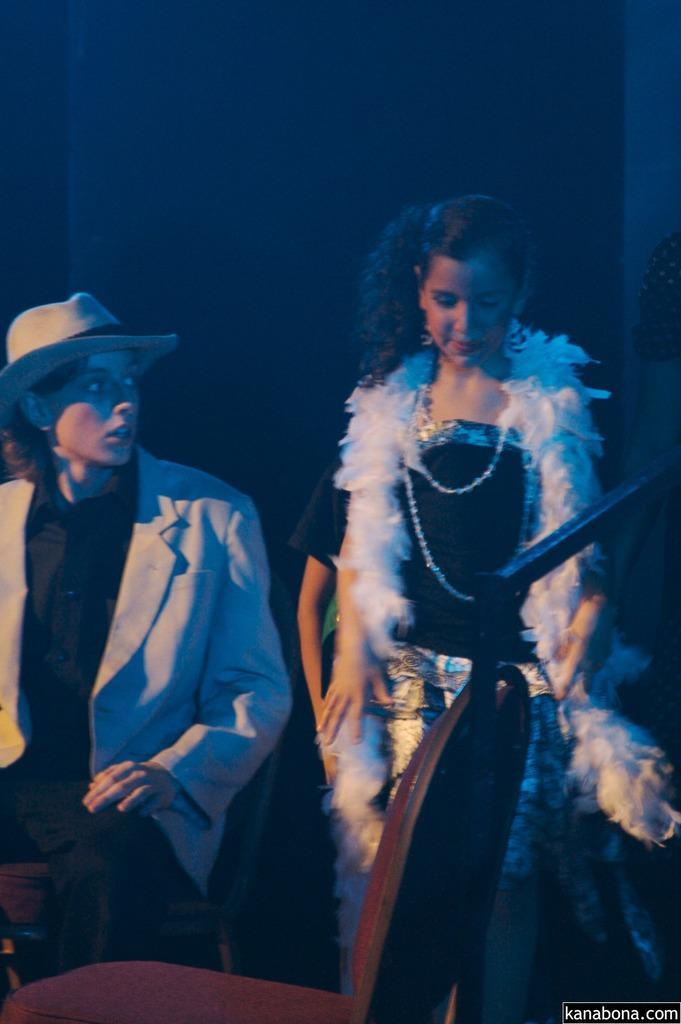Please provide a concise description of this image. In this image a woman is standing beside to a person wearing suit. He is sitting on the chair. He is wearing a cap. Background there is wall. Before them there is a chair. 